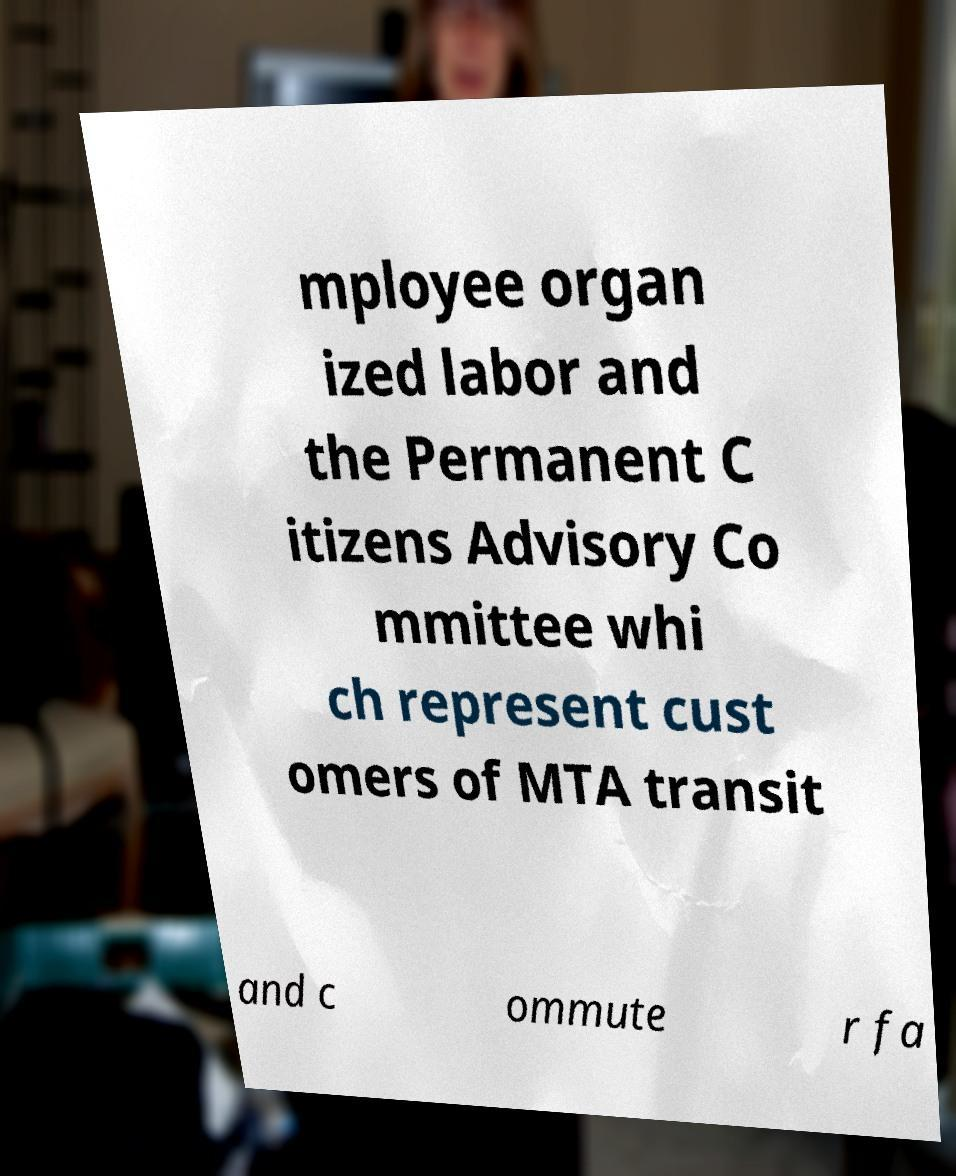Please read and relay the text visible in this image. What does it say? mployee organ ized labor and the Permanent C itizens Advisory Co mmittee whi ch represent cust omers of MTA transit and c ommute r fa 